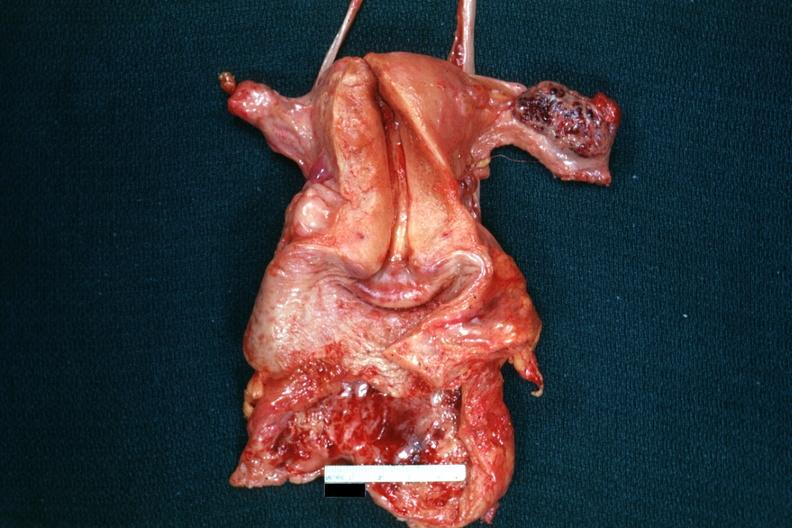s acrocyanosis present?
Answer the question using a single word or phrase. No 